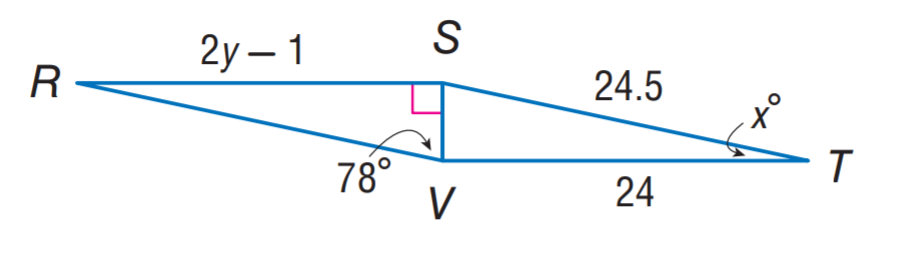Question: \triangle R S V \cong \triangle T V S. Find y.
Choices:
A. 11
B. 11.5
C. 12
D. 12.5
Answer with the letter. Answer: D 